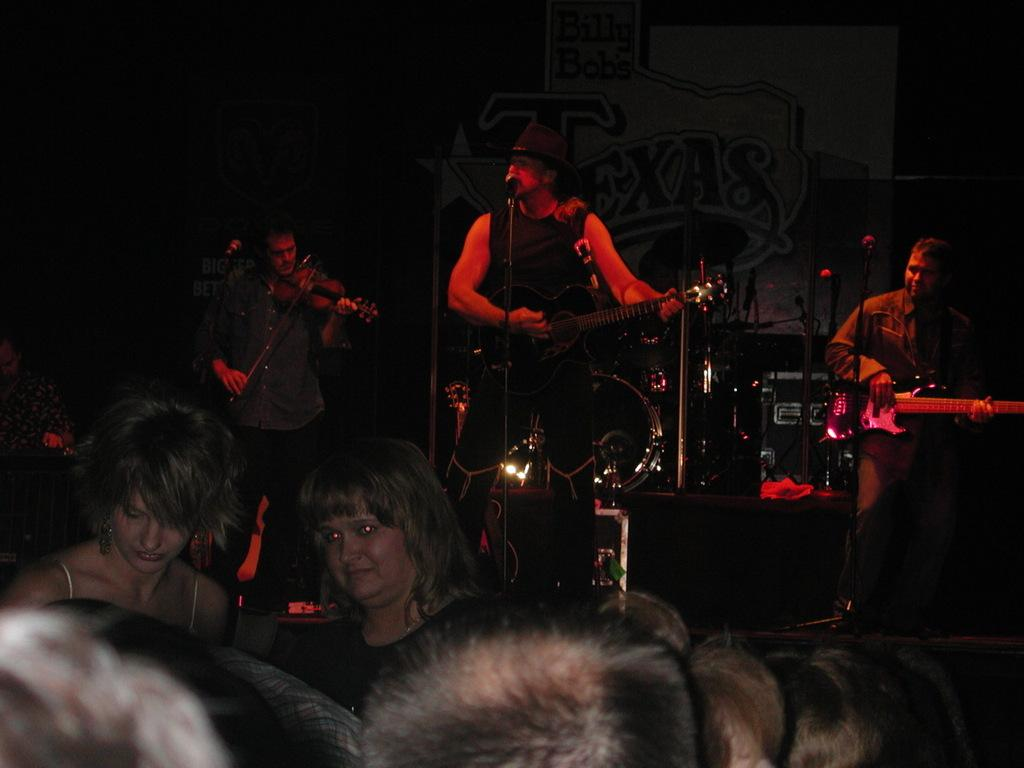How many people are in the image? There are people in the image, specifically three people. Where are the three people located in the image? The three people are standing on a stage. What are the three people holding in the image? The three people are holding guitars. What objects are in front of the people on the stage? There are microphones (mics) in front of the people. Can you see any bats flying around the people on the stage? There are no bats visible in the image; it features people standing on a stage with guitars and microphones. Are there any popcorn kernels scattered on the stage? There is no mention of popcorn in the image, and it does not appear to be related to the scene depicted. 